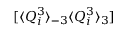Convert formula to latex. <formula><loc_0><loc_0><loc_500><loc_500>[ \langle Q _ { i } ^ { 3 } \rangle _ { - 3 } \langle Q _ { i } ^ { 3 } \rangle _ { 3 } ]</formula> 